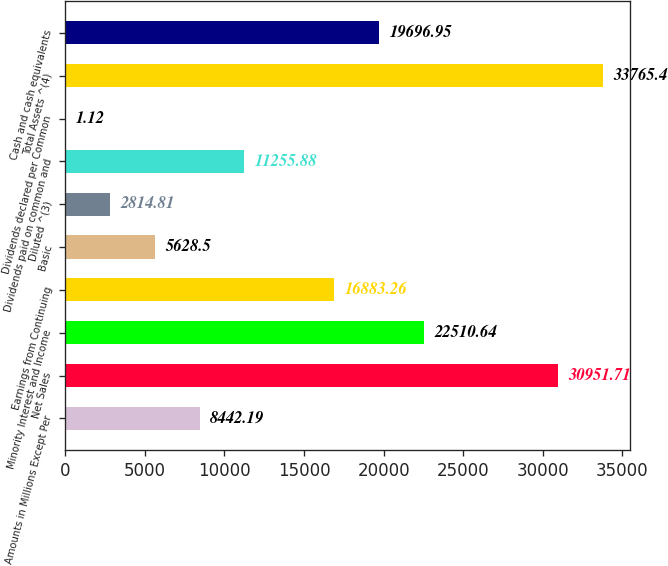Convert chart to OTSL. <chart><loc_0><loc_0><loc_500><loc_500><bar_chart><fcel>Amounts in Millions Except Per<fcel>Net Sales<fcel>Minority Interest and Income<fcel>Earnings from Continuing<fcel>Basic<fcel>Diluted ^(3)<fcel>Dividends paid on common and<fcel>Dividends declared per Common<fcel>Total Assets ^(4)<fcel>Cash and cash equivalents<nl><fcel>8442.19<fcel>30951.7<fcel>22510.6<fcel>16883.3<fcel>5628.5<fcel>2814.81<fcel>11255.9<fcel>1.12<fcel>33765.4<fcel>19697<nl></chart> 